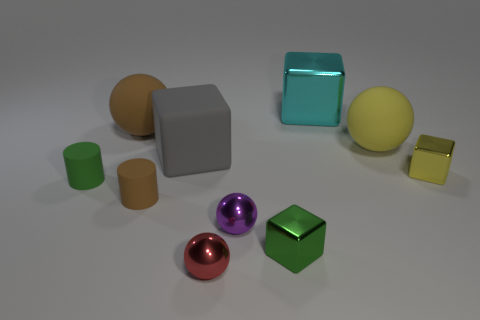Subtract all cylinders. How many objects are left? 8 Add 6 big metal blocks. How many big metal blocks exist? 7 Subtract 0 green spheres. How many objects are left? 10 Subtract all big brown matte objects. Subtract all large matte cubes. How many objects are left? 8 Add 5 large yellow rubber balls. How many large yellow rubber balls are left? 6 